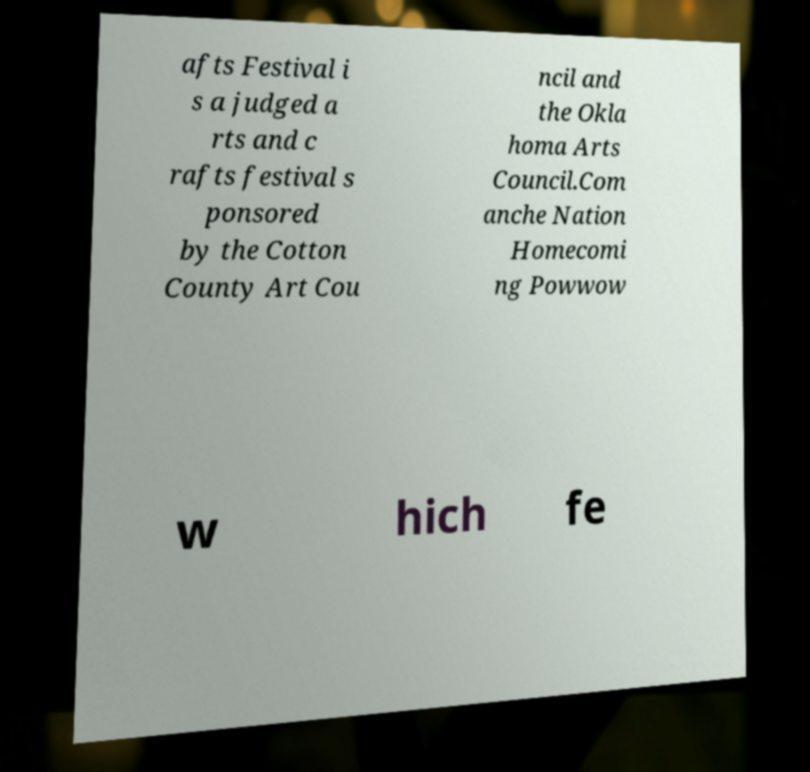Please read and relay the text visible in this image. What does it say? afts Festival i s a judged a rts and c rafts festival s ponsored by the Cotton County Art Cou ncil and the Okla homa Arts Council.Com anche Nation Homecomi ng Powwow w hich fe 